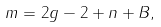Convert formula to latex. <formula><loc_0><loc_0><loc_500><loc_500>m = 2 g - 2 + n + B ,</formula> 